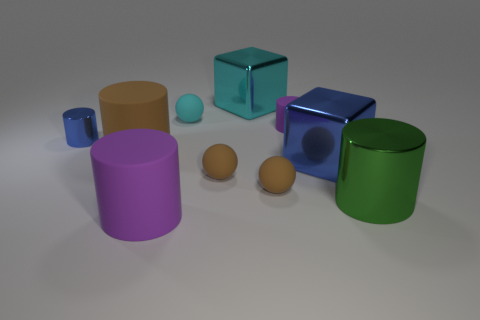Is the size of the cylinder to the left of the brown matte cylinder the same as the blue cube?
Make the answer very short. No. The object that is the same color as the tiny matte cylinder is what size?
Your response must be concise. Large. Are there any purple cylinders that have the same size as the green metal cylinder?
Provide a short and direct response. Yes. Is the color of the large rubber cylinder that is behind the big purple matte object the same as the sphere that is to the right of the cyan block?
Give a very brief answer. Yes. Is there a block that has the same color as the tiny metallic thing?
Your response must be concise. Yes. How many other things are the same shape as the big cyan metallic thing?
Your response must be concise. 1. There is a big rubber object behind the blue cube; what is its shape?
Offer a very short reply. Cylinder. Does the big blue object have the same shape as the purple rubber object left of the tiny cyan matte object?
Give a very brief answer. No. What size is the cylinder that is both behind the large brown object and on the right side of the blue cylinder?
Your response must be concise. Small. There is a rubber cylinder that is both behind the green metal thing and in front of the blue cylinder; what is its color?
Your answer should be very brief. Brown. 